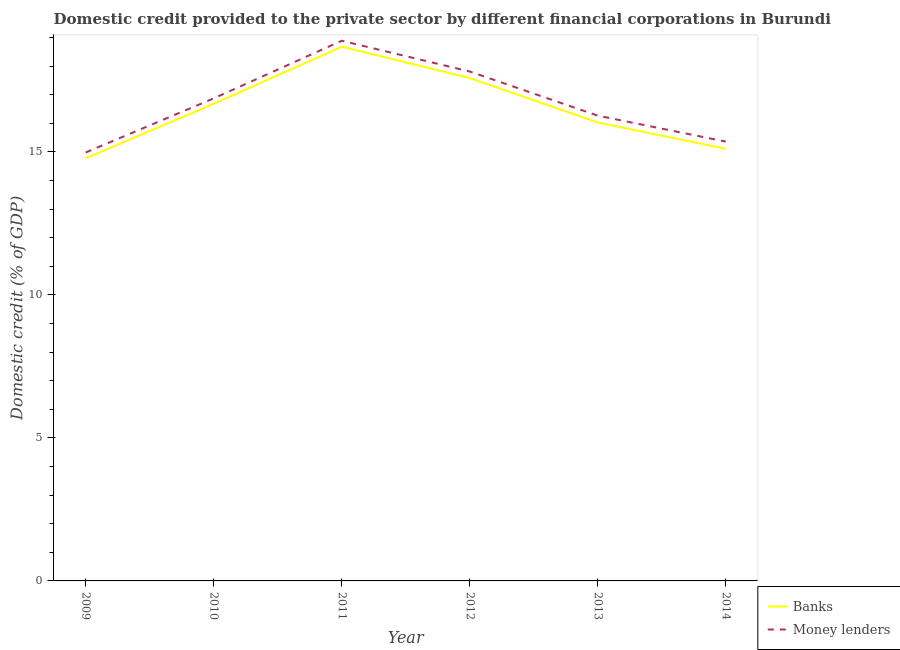How many different coloured lines are there?
Offer a terse response. 2. What is the domestic credit provided by money lenders in 2013?
Give a very brief answer. 16.27. Across all years, what is the maximum domestic credit provided by banks?
Keep it short and to the point. 18.68. Across all years, what is the minimum domestic credit provided by money lenders?
Provide a succinct answer. 14.98. In which year was the domestic credit provided by banks maximum?
Ensure brevity in your answer.  2011. In which year was the domestic credit provided by banks minimum?
Ensure brevity in your answer.  2009. What is the total domestic credit provided by money lenders in the graph?
Ensure brevity in your answer.  100.18. What is the difference between the domestic credit provided by money lenders in 2009 and that in 2012?
Give a very brief answer. -2.83. What is the difference between the domestic credit provided by money lenders in 2012 and the domestic credit provided by banks in 2010?
Make the answer very short. 1.13. What is the average domestic credit provided by money lenders per year?
Make the answer very short. 16.7. In the year 2011, what is the difference between the domestic credit provided by banks and domestic credit provided by money lenders?
Offer a very short reply. -0.21. What is the ratio of the domestic credit provided by banks in 2010 to that in 2013?
Provide a succinct answer. 1.04. Is the domestic credit provided by money lenders in 2009 less than that in 2014?
Provide a short and direct response. Yes. What is the difference between the highest and the second highest domestic credit provided by money lenders?
Ensure brevity in your answer.  1.08. What is the difference between the highest and the lowest domestic credit provided by banks?
Ensure brevity in your answer.  3.9. Is the sum of the domestic credit provided by banks in 2010 and 2012 greater than the maximum domestic credit provided by money lenders across all years?
Your answer should be compact. Yes. Does the domestic credit provided by banks monotonically increase over the years?
Offer a terse response. No. Is the domestic credit provided by money lenders strictly greater than the domestic credit provided by banks over the years?
Your answer should be very brief. Yes. Is the domestic credit provided by money lenders strictly less than the domestic credit provided by banks over the years?
Your response must be concise. No. How many lines are there?
Give a very brief answer. 2. How many years are there in the graph?
Provide a short and direct response. 6. Are the values on the major ticks of Y-axis written in scientific E-notation?
Ensure brevity in your answer.  No. Where does the legend appear in the graph?
Make the answer very short. Bottom right. How many legend labels are there?
Provide a succinct answer. 2. How are the legend labels stacked?
Ensure brevity in your answer.  Vertical. What is the title of the graph?
Give a very brief answer. Domestic credit provided to the private sector by different financial corporations in Burundi. What is the label or title of the Y-axis?
Your response must be concise. Domestic credit (% of GDP). What is the Domestic credit (% of GDP) in Banks in 2009?
Offer a very short reply. 14.78. What is the Domestic credit (% of GDP) of Money lenders in 2009?
Provide a succinct answer. 14.98. What is the Domestic credit (% of GDP) in Banks in 2010?
Make the answer very short. 16.68. What is the Domestic credit (% of GDP) in Money lenders in 2010?
Offer a terse response. 16.87. What is the Domestic credit (% of GDP) in Banks in 2011?
Make the answer very short. 18.68. What is the Domestic credit (% of GDP) of Money lenders in 2011?
Your answer should be very brief. 18.89. What is the Domestic credit (% of GDP) of Banks in 2012?
Your response must be concise. 17.58. What is the Domestic credit (% of GDP) of Money lenders in 2012?
Provide a succinct answer. 17.81. What is the Domestic credit (% of GDP) of Banks in 2013?
Keep it short and to the point. 16.03. What is the Domestic credit (% of GDP) in Money lenders in 2013?
Keep it short and to the point. 16.27. What is the Domestic credit (% of GDP) in Banks in 2014?
Ensure brevity in your answer.  15.11. What is the Domestic credit (% of GDP) in Money lenders in 2014?
Ensure brevity in your answer.  15.36. Across all years, what is the maximum Domestic credit (% of GDP) of Banks?
Ensure brevity in your answer.  18.68. Across all years, what is the maximum Domestic credit (% of GDP) in Money lenders?
Make the answer very short. 18.89. Across all years, what is the minimum Domestic credit (% of GDP) of Banks?
Give a very brief answer. 14.78. Across all years, what is the minimum Domestic credit (% of GDP) in Money lenders?
Keep it short and to the point. 14.98. What is the total Domestic credit (% of GDP) in Banks in the graph?
Ensure brevity in your answer.  98.86. What is the total Domestic credit (% of GDP) in Money lenders in the graph?
Your answer should be compact. 100.18. What is the difference between the Domestic credit (% of GDP) of Banks in 2009 and that in 2010?
Provide a short and direct response. -1.91. What is the difference between the Domestic credit (% of GDP) in Money lenders in 2009 and that in 2010?
Your response must be concise. -1.89. What is the difference between the Domestic credit (% of GDP) of Money lenders in 2009 and that in 2011?
Make the answer very short. -3.91. What is the difference between the Domestic credit (% of GDP) of Banks in 2009 and that in 2012?
Keep it short and to the point. -2.8. What is the difference between the Domestic credit (% of GDP) of Money lenders in 2009 and that in 2012?
Provide a succinct answer. -2.83. What is the difference between the Domestic credit (% of GDP) of Banks in 2009 and that in 2013?
Your response must be concise. -1.25. What is the difference between the Domestic credit (% of GDP) in Money lenders in 2009 and that in 2013?
Give a very brief answer. -1.29. What is the difference between the Domestic credit (% of GDP) of Banks in 2009 and that in 2014?
Give a very brief answer. -0.33. What is the difference between the Domestic credit (% of GDP) of Money lenders in 2009 and that in 2014?
Provide a short and direct response. -0.38. What is the difference between the Domestic credit (% of GDP) of Banks in 2010 and that in 2011?
Your response must be concise. -1.99. What is the difference between the Domestic credit (% of GDP) in Money lenders in 2010 and that in 2011?
Give a very brief answer. -2.01. What is the difference between the Domestic credit (% of GDP) in Banks in 2010 and that in 2012?
Provide a succinct answer. -0.9. What is the difference between the Domestic credit (% of GDP) in Money lenders in 2010 and that in 2012?
Make the answer very short. -0.94. What is the difference between the Domestic credit (% of GDP) in Banks in 2010 and that in 2013?
Provide a succinct answer. 0.66. What is the difference between the Domestic credit (% of GDP) in Money lenders in 2010 and that in 2013?
Offer a very short reply. 0.6. What is the difference between the Domestic credit (% of GDP) of Banks in 2010 and that in 2014?
Your answer should be compact. 1.58. What is the difference between the Domestic credit (% of GDP) in Money lenders in 2010 and that in 2014?
Provide a short and direct response. 1.51. What is the difference between the Domestic credit (% of GDP) in Banks in 2011 and that in 2012?
Offer a very short reply. 1.1. What is the difference between the Domestic credit (% of GDP) of Money lenders in 2011 and that in 2012?
Give a very brief answer. 1.08. What is the difference between the Domestic credit (% of GDP) of Banks in 2011 and that in 2013?
Ensure brevity in your answer.  2.65. What is the difference between the Domestic credit (% of GDP) in Money lenders in 2011 and that in 2013?
Your response must be concise. 2.62. What is the difference between the Domestic credit (% of GDP) of Banks in 2011 and that in 2014?
Offer a terse response. 3.57. What is the difference between the Domestic credit (% of GDP) of Money lenders in 2011 and that in 2014?
Give a very brief answer. 3.53. What is the difference between the Domestic credit (% of GDP) of Banks in 2012 and that in 2013?
Ensure brevity in your answer.  1.55. What is the difference between the Domestic credit (% of GDP) in Money lenders in 2012 and that in 2013?
Provide a short and direct response. 1.54. What is the difference between the Domestic credit (% of GDP) in Banks in 2012 and that in 2014?
Give a very brief answer. 2.47. What is the difference between the Domestic credit (% of GDP) of Money lenders in 2012 and that in 2014?
Your answer should be compact. 2.45. What is the difference between the Domestic credit (% of GDP) of Banks in 2013 and that in 2014?
Provide a succinct answer. 0.92. What is the difference between the Domestic credit (% of GDP) of Money lenders in 2013 and that in 2014?
Your answer should be very brief. 0.91. What is the difference between the Domestic credit (% of GDP) in Banks in 2009 and the Domestic credit (% of GDP) in Money lenders in 2010?
Provide a succinct answer. -2.09. What is the difference between the Domestic credit (% of GDP) of Banks in 2009 and the Domestic credit (% of GDP) of Money lenders in 2011?
Make the answer very short. -4.11. What is the difference between the Domestic credit (% of GDP) of Banks in 2009 and the Domestic credit (% of GDP) of Money lenders in 2012?
Offer a very short reply. -3.03. What is the difference between the Domestic credit (% of GDP) in Banks in 2009 and the Domestic credit (% of GDP) in Money lenders in 2013?
Your response must be concise. -1.49. What is the difference between the Domestic credit (% of GDP) of Banks in 2009 and the Domestic credit (% of GDP) of Money lenders in 2014?
Provide a short and direct response. -0.58. What is the difference between the Domestic credit (% of GDP) in Banks in 2010 and the Domestic credit (% of GDP) in Money lenders in 2011?
Provide a short and direct response. -2.2. What is the difference between the Domestic credit (% of GDP) in Banks in 2010 and the Domestic credit (% of GDP) in Money lenders in 2012?
Offer a very short reply. -1.13. What is the difference between the Domestic credit (% of GDP) of Banks in 2010 and the Domestic credit (% of GDP) of Money lenders in 2013?
Offer a very short reply. 0.42. What is the difference between the Domestic credit (% of GDP) in Banks in 2010 and the Domestic credit (% of GDP) in Money lenders in 2014?
Your response must be concise. 1.32. What is the difference between the Domestic credit (% of GDP) in Banks in 2011 and the Domestic credit (% of GDP) in Money lenders in 2012?
Offer a terse response. 0.87. What is the difference between the Domestic credit (% of GDP) of Banks in 2011 and the Domestic credit (% of GDP) of Money lenders in 2013?
Ensure brevity in your answer.  2.41. What is the difference between the Domestic credit (% of GDP) of Banks in 2011 and the Domestic credit (% of GDP) of Money lenders in 2014?
Ensure brevity in your answer.  3.32. What is the difference between the Domestic credit (% of GDP) of Banks in 2012 and the Domestic credit (% of GDP) of Money lenders in 2013?
Keep it short and to the point. 1.31. What is the difference between the Domestic credit (% of GDP) in Banks in 2012 and the Domestic credit (% of GDP) in Money lenders in 2014?
Ensure brevity in your answer.  2.22. What is the difference between the Domestic credit (% of GDP) of Banks in 2013 and the Domestic credit (% of GDP) of Money lenders in 2014?
Offer a terse response. 0.67. What is the average Domestic credit (% of GDP) in Banks per year?
Your answer should be very brief. 16.48. What is the average Domestic credit (% of GDP) in Money lenders per year?
Make the answer very short. 16.7. In the year 2009, what is the difference between the Domestic credit (% of GDP) of Banks and Domestic credit (% of GDP) of Money lenders?
Your answer should be very brief. -0.2. In the year 2010, what is the difference between the Domestic credit (% of GDP) in Banks and Domestic credit (% of GDP) in Money lenders?
Your response must be concise. -0.19. In the year 2011, what is the difference between the Domestic credit (% of GDP) of Banks and Domestic credit (% of GDP) of Money lenders?
Give a very brief answer. -0.21. In the year 2012, what is the difference between the Domestic credit (% of GDP) in Banks and Domestic credit (% of GDP) in Money lenders?
Make the answer very short. -0.23. In the year 2013, what is the difference between the Domestic credit (% of GDP) of Banks and Domestic credit (% of GDP) of Money lenders?
Your answer should be compact. -0.24. In the year 2014, what is the difference between the Domestic credit (% of GDP) in Banks and Domestic credit (% of GDP) in Money lenders?
Provide a short and direct response. -0.25. What is the ratio of the Domestic credit (% of GDP) of Banks in 2009 to that in 2010?
Give a very brief answer. 0.89. What is the ratio of the Domestic credit (% of GDP) in Money lenders in 2009 to that in 2010?
Make the answer very short. 0.89. What is the ratio of the Domestic credit (% of GDP) in Banks in 2009 to that in 2011?
Make the answer very short. 0.79. What is the ratio of the Domestic credit (% of GDP) of Money lenders in 2009 to that in 2011?
Your answer should be very brief. 0.79. What is the ratio of the Domestic credit (% of GDP) in Banks in 2009 to that in 2012?
Your response must be concise. 0.84. What is the ratio of the Domestic credit (% of GDP) in Money lenders in 2009 to that in 2012?
Provide a short and direct response. 0.84. What is the ratio of the Domestic credit (% of GDP) in Banks in 2009 to that in 2013?
Keep it short and to the point. 0.92. What is the ratio of the Domestic credit (% of GDP) of Money lenders in 2009 to that in 2013?
Ensure brevity in your answer.  0.92. What is the ratio of the Domestic credit (% of GDP) in Banks in 2009 to that in 2014?
Provide a succinct answer. 0.98. What is the ratio of the Domestic credit (% of GDP) in Money lenders in 2009 to that in 2014?
Give a very brief answer. 0.98. What is the ratio of the Domestic credit (% of GDP) in Banks in 2010 to that in 2011?
Provide a short and direct response. 0.89. What is the ratio of the Domestic credit (% of GDP) in Money lenders in 2010 to that in 2011?
Provide a short and direct response. 0.89. What is the ratio of the Domestic credit (% of GDP) in Banks in 2010 to that in 2012?
Your answer should be compact. 0.95. What is the ratio of the Domestic credit (% of GDP) in Money lenders in 2010 to that in 2012?
Provide a short and direct response. 0.95. What is the ratio of the Domestic credit (% of GDP) in Banks in 2010 to that in 2013?
Ensure brevity in your answer.  1.04. What is the ratio of the Domestic credit (% of GDP) of Money lenders in 2010 to that in 2013?
Ensure brevity in your answer.  1.04. What is the ratio of the Domestic credit (% of GDP) in Banks in 2010 to that in 2014?
Offer a terse response. 1.1. What is the ratio of the Domestic credit (% of GDP) in Money lenders in 2010 to that in 2014?
Your response must be concise. 1.1. What is the ratio of the Domestic credit (% of GDP) in Banks in 2011 to that in 2012?
Make the answer very short. 1.06. What is the ratio of the Domestic credit (% of GDP) in Money lenders in 2011 to that in 2012?
Offer a very short reply. 1.06. What is the ratio of the Domestic credit (% of GDP) in Banks in 2011 to that in 2013?
Your response must be concise. 1.17. What is the ratio of the Domestic credit (% of GDP) of Money lenders in 2011 to that in 2013?
Your answer should be compact. 1.16. What is the ratio of the Domestic credit (% of GDP) in Banks in 2011 to that in 2014?
Provide a succinct answer. 1.24. What is the ratio of the Domestic credit (% of GDP) in Money lenders in 2011 to that in 2014?
Make the answer very short. 1.23. What is the ratio of the Domestic credit (% of GDP) of Banks in 2012 to that in 2013?
Offer a terse response. 1.1. What is the ratio of the Domestic credit (% of GDP) in Money lenders in 2012 to that in 2013?
Provide a succinct answer. 1.09. What is the ratio of the Domestic credit (% of GDP) in Banks in 2012 to that in 2014?
Your answer should be compact. 1.16. What is the ratio of the Domestic credit (% of GDP) of Money lenders in 2012 to that in 2014?
Provide a short and direct response. 1.16. What is the ratio of the Domestic credit (% of GDP) of Banks in 2013 to that in 2014?
Make the answer very short. 1.06. What is the ratio of the Domestic credit (% of GDP) in Money lenders in 2013 to that in 2014?
Ensure brevity in your answer.  1.06. What is the difference between the highest and the second highest Domestic credit (% of GDP) of Banks?
Your answer should be very brief. 1.1. What is the difference between the highest and the second highest Domestic credit (% of GDP) in Money lenders?
Offer a very short reply. 1.08. What is the difference between the highest and the lowest Domestic credit (% of GDP) of Banks?
Offer a very short reply. 3.9. What is the difference between the highest and the lowest Domestic credit (% of GDP) in Money lenders?
Your response must be concise. 3.91. 